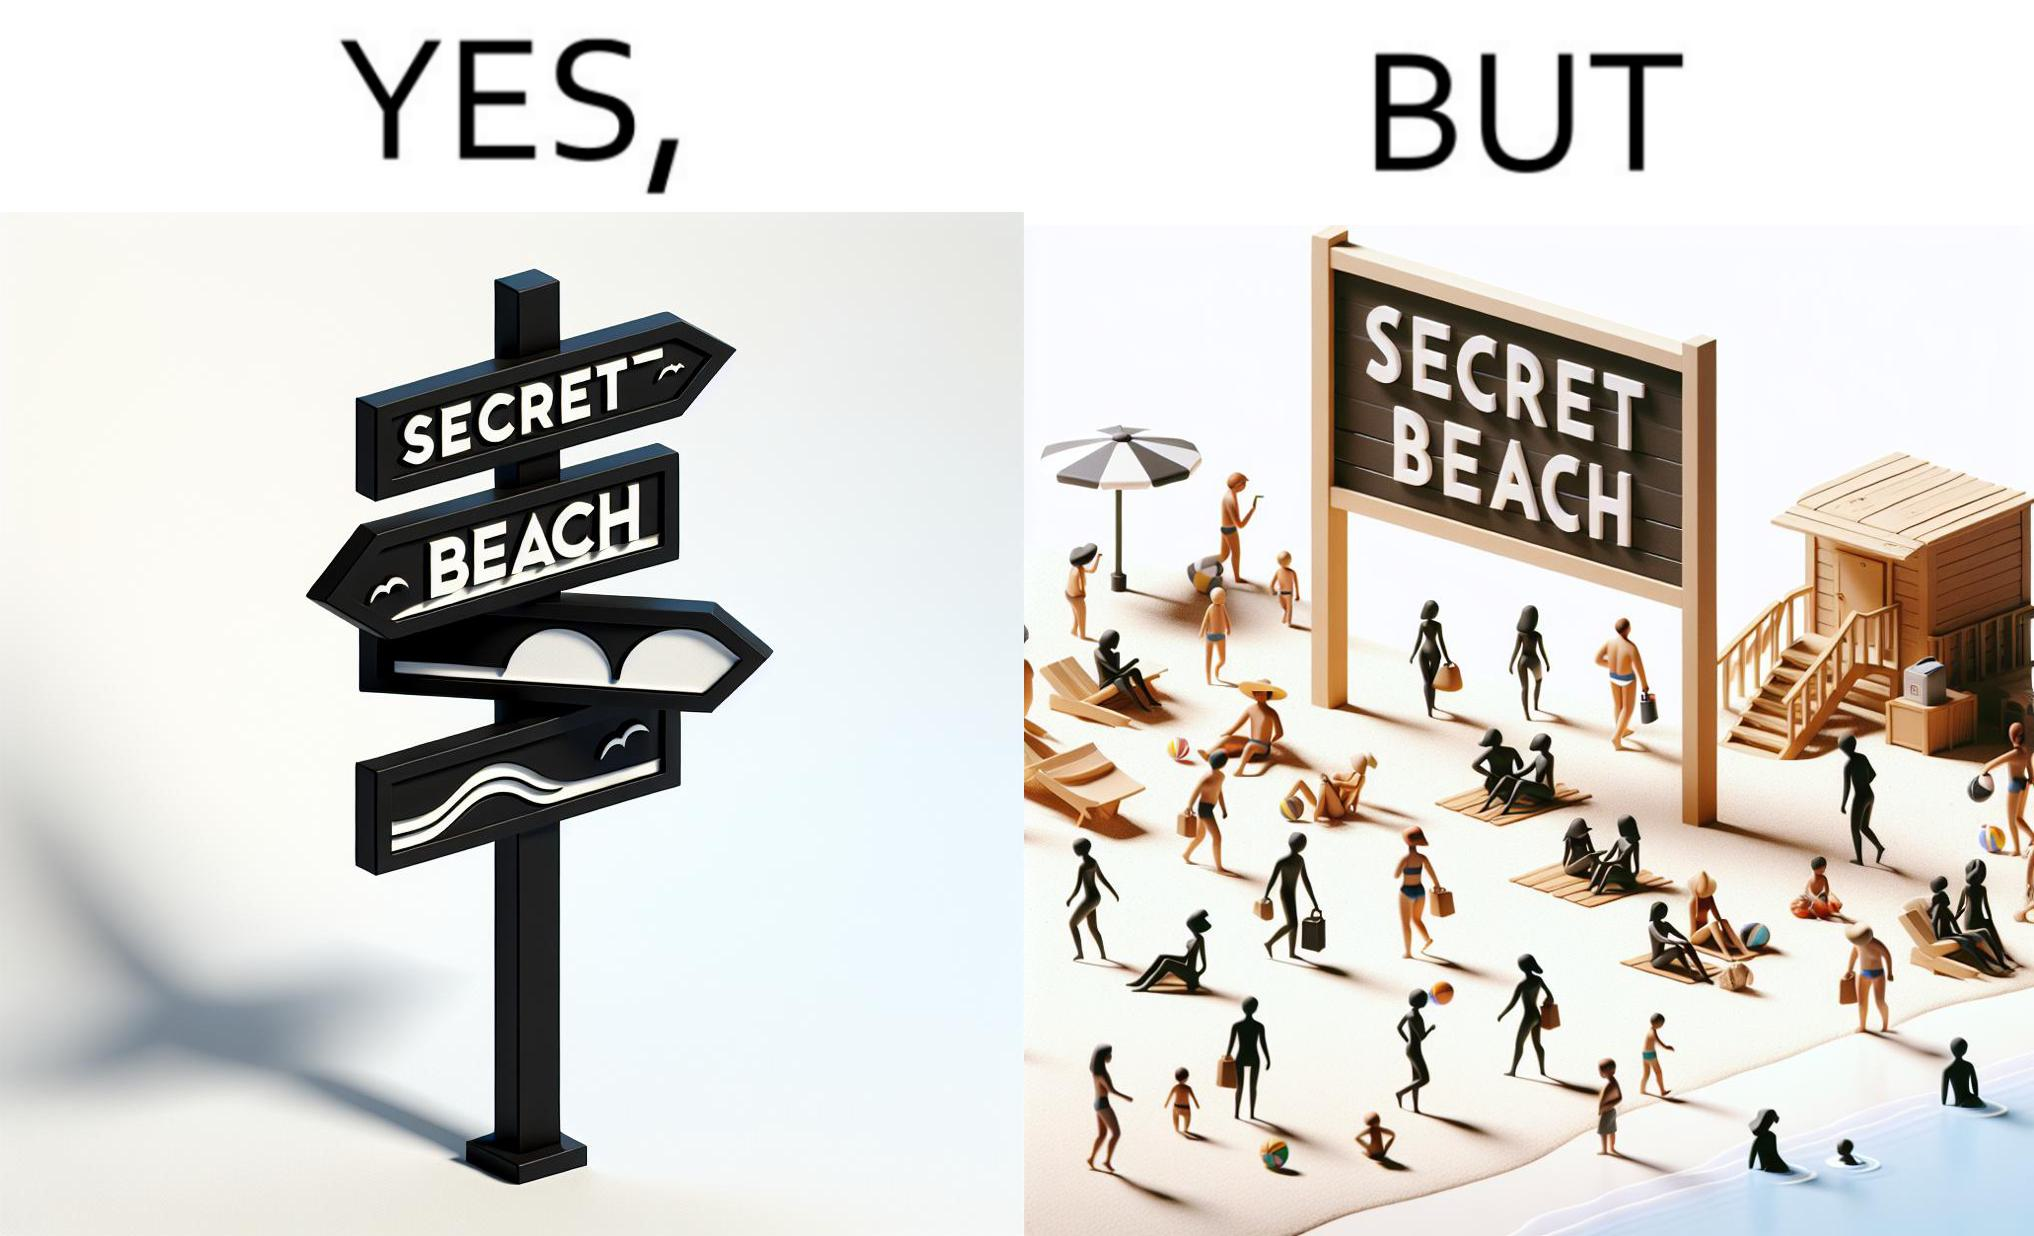What is shown in this image? The image is ironical, as people can be seen in the beach, and is clearly not a secret, while the board at the entrance has "Secret Beach" written on it. 